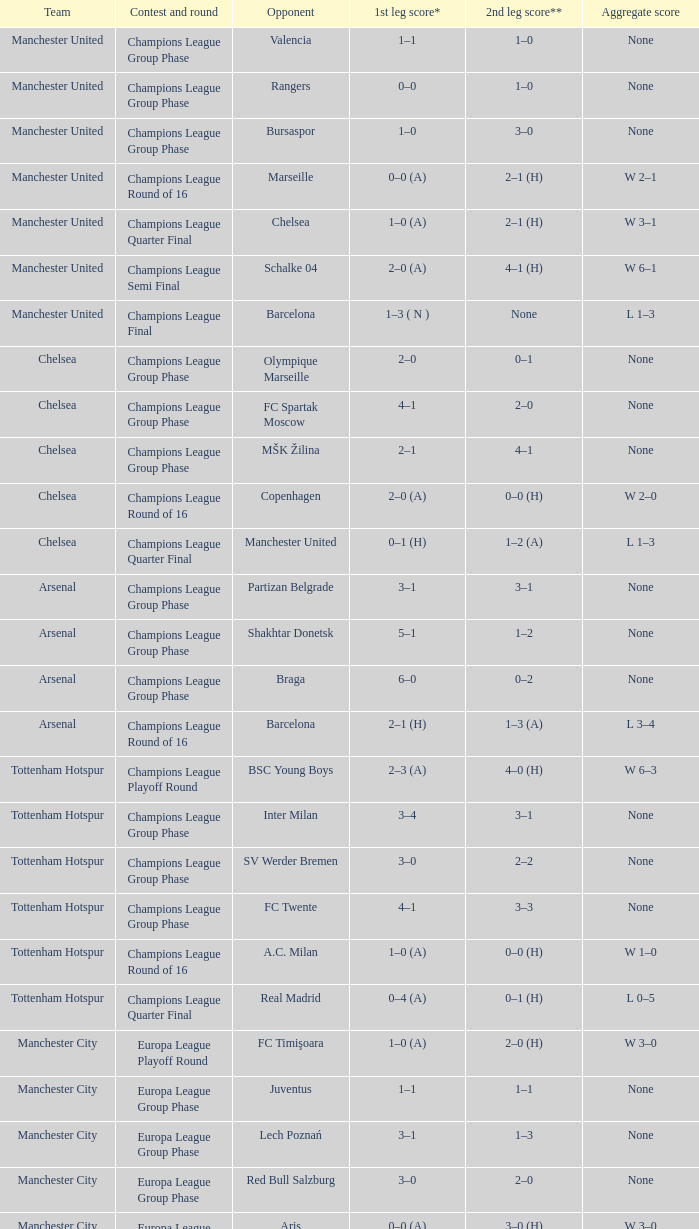During the first leg of the game featuring liverpool and trabzonspor, how many goals were scored by each team? 1–0 (H). 